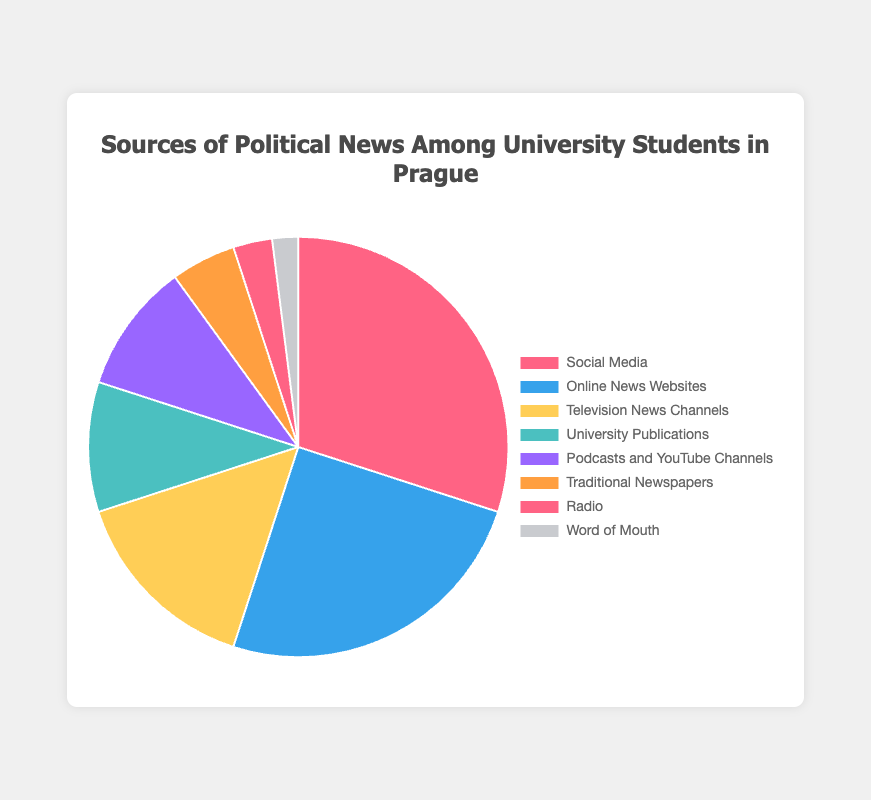Which source is the most used for political news among university students in Prague? The figure shows that Social Media has the largest section, indicating it is the most used source.
Answer: Social Media What percentage of students get their political news from traditional newspapers and radio combined? The percentages for Traditional Newspapers and Radio are 5% and 3% respectively. Adding these together gives 5% + 3% = 8%.
Answer: 8% How much more popular is Online News Websites compared to Television News Channels? The percentage for Online News Websites is 25% and for Television News Channels it is 15%. The difference is 25% - 15% = 10%.
Answer: 10% Which sources have the smallest and second smallest percentage of usage among students? From the figure, Word of Mouth (2%) and Radio (3%) have the smallest and second smallest percentages respectively.
Answer: Word of Mouth, Radio Compare the combined usage of University Publications and Podcasts/YouTube Channels with Social Media. Which is higher? University Publications and Podcasts/YouTube Channels each have 10%, combining them gives 10% + 10% = 20%. Social Media has 30%. Therefore, Social Media (30%) is higher than the combined figure (20%).
Answer: Social Media What is the combined percentage of students using sources other than Social Media, Online News Websites, and Television News Channels? Adding the percentages of University Publications (10%), Podcasts and YouTube Channels (10%), Traditional Newspapers (5%), Radio (3%), and Word of Mouth (2%) gives 10% + 10% + 5% + 3% + 2% = 30%.
Answer: 30% Of the sources listed, which shares the same percentage of usage? University Publications and Podcasts/YouTube Channels both have a 10% usage rate.
Answer: University Publications, Podcasts/YouTube Channels Which source has the second highest usage for political news? After Social Media (30%), Online News Websites come next with 25%.
Answer: Online News Websites How does the usage percentage of Television News Channels compare to that of Traditional Newspapers? Television News Channels have a usage rate of 15%, while Traditional Newspapers have 5%. Television News Channels are 10% higher.
Answer: 15% is 10% higher than 5% What is the visual color representation for Social Media and Radio on the chart? Social Media is represented by the color red (lighter pink shade), and Radio by a shade of grey.
Answer: Red, Grey 